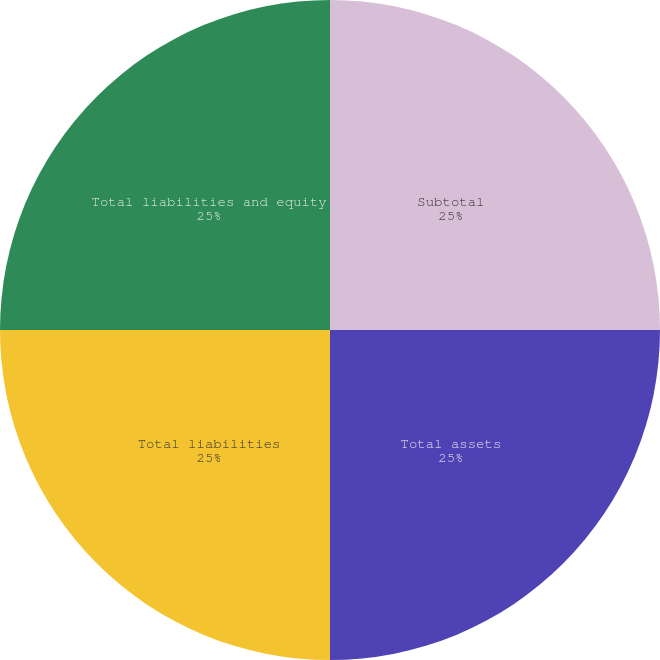Convert chart. <chart><loc_0><loc_0><loc_500><loc_500><pie_chart><fcel>Subtotal<fcel>Total assets<fcel>Total liabilities<fcel>Total liabilities and equity<nl><fcel>25.0%<fcel>25.0%<fcel>25.0%<fcel>25.0%<nl></chart> 